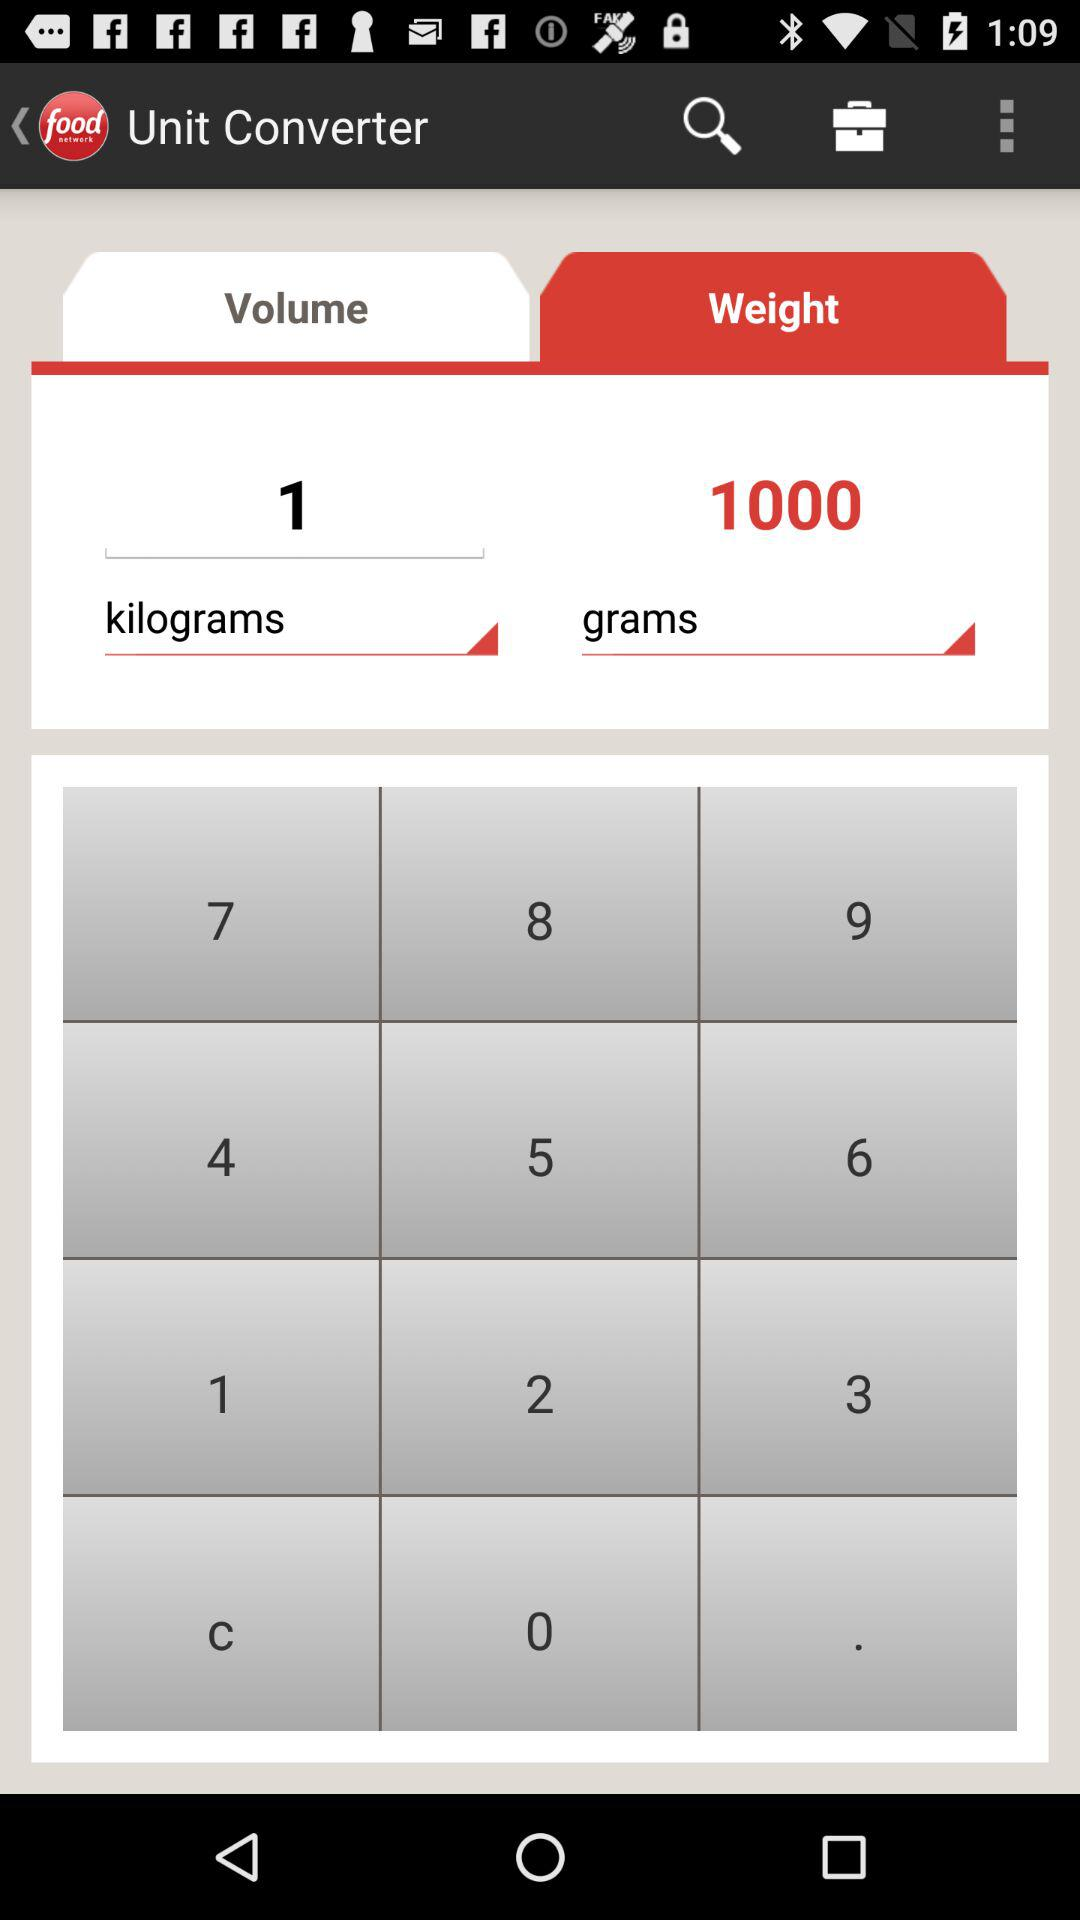What is the weight? The weight is 1 kilogram. 